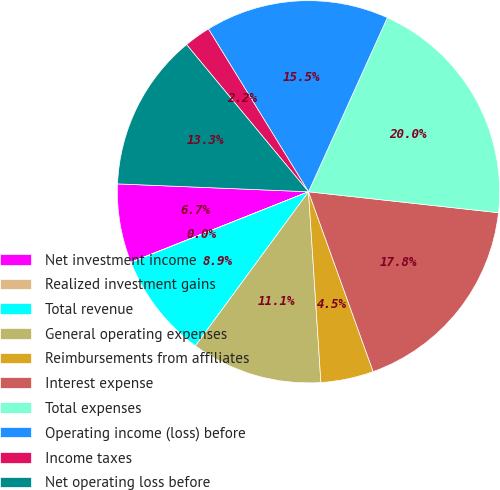Convert chart. <chart><loc_0><loc_0><loc_500><loc_500><pie_chart><fcel>Net investment income<fcel>Realized investment gains<fcel>Total revenue<fcel>General operating expenses<fcel>Reimbursements from affiliates<fcel>Interest expense<fcel>Total expenses<fcel>Operating income (loss) before<fcel>Income taxes<fcel>Net operating loss before<nl><fcel>6.67%<fcel>0.02%<fcel>8.89%<fcel>11.11%<fcel>4.46%<fcel>17.76%<fcel>19.98%<fcel>15.54%<fcel>2.24%<fcel>13.33%<nl></chart> 